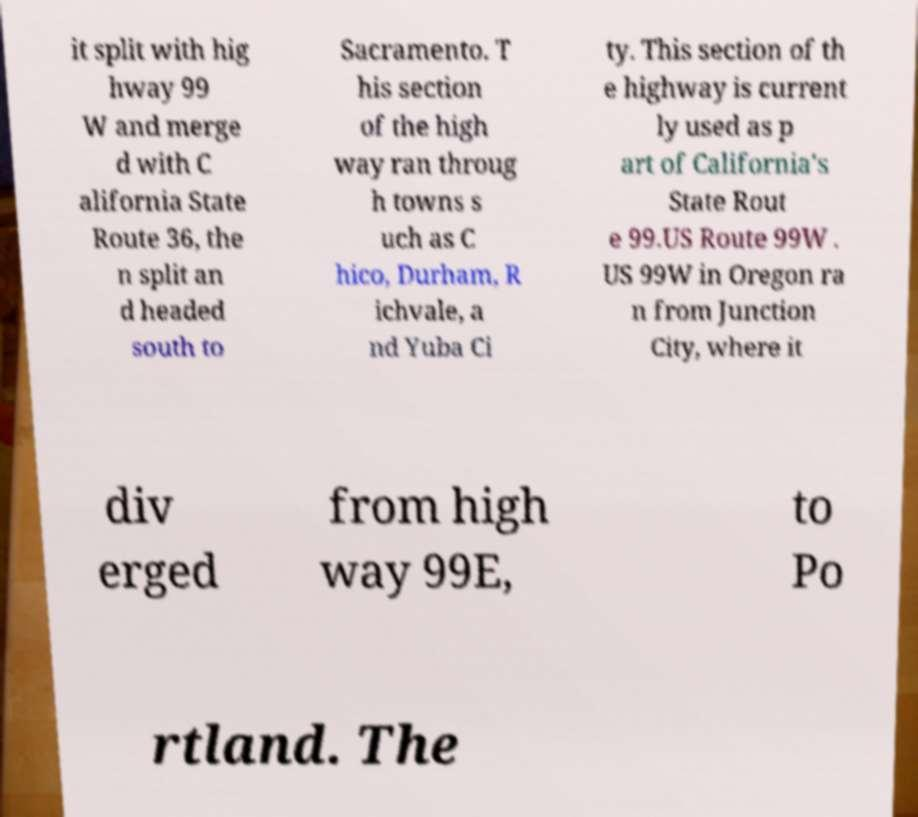Can you accurately transcribe the text from the provided image for me? it split with hig hway 99 W and merge d with C alifornia State Route 36, the n split an d headed south to Sacramento. T his section of the high way ran throug h towns s uch as C hico, Durham, R ichvale, a nd Yuba Ci ty. This section of th e highway is current ly used as p art of California's State Rout e 99.US Route 99W . US 99W in Oregon ra n from Junction City, where it div erged from high way 99E, to Po rtland. The 